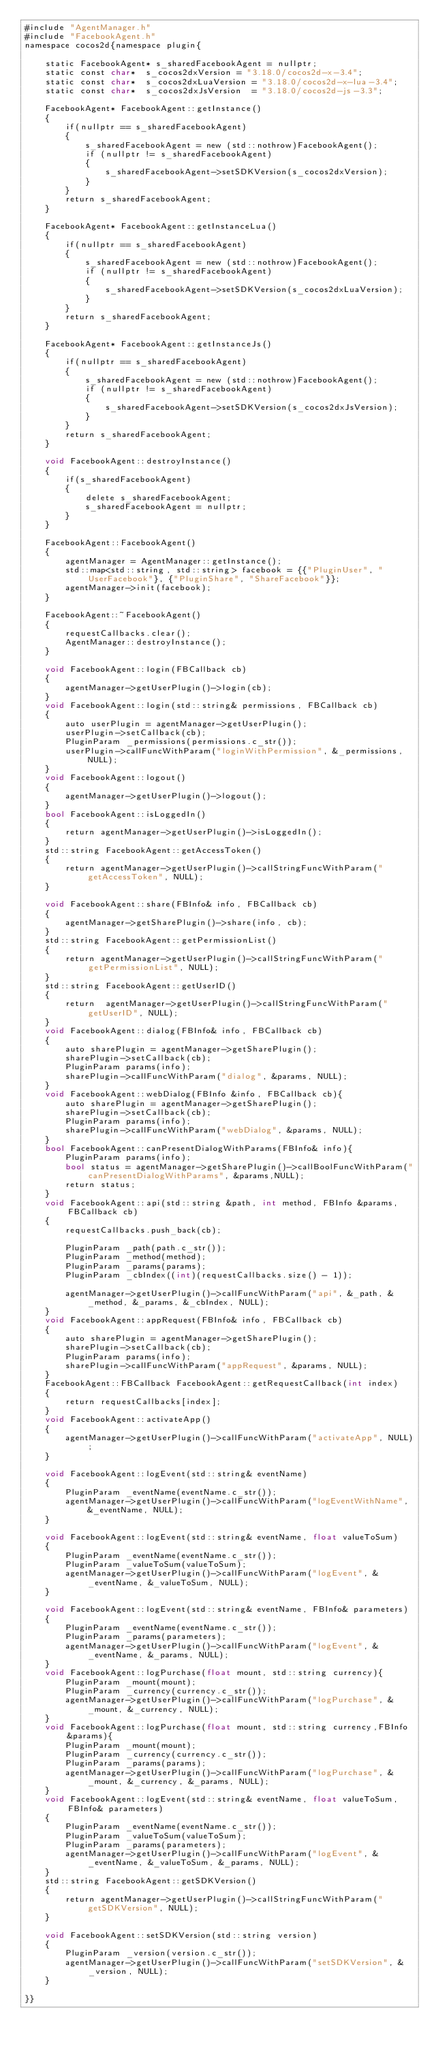<code> <loc_0><loc_0><loc_500><loc_500><_ObjectiveC_>#include "AgentManager.h"
#include "FacebookAgent.h"
namespace cocos2d{namespace plugin{
    
    static FacebookAgent* s_sharedFacebookAgent = nullptr;
    static const char*  s_cocos2dxVersion = "3.18.0/cocos2d-x-3.4";
    static const char*  s_cocos2dxLuaVersion = "3.18.0/cocos2d-x-lua-3.4";
    static const char*  s_cocos2dxJsVersion  = "3.18.0/cocos2d-js-3.3";
    
    FacebookAgent* FacebookAgent::getInstance()
    {
        if(nullptr == s_sharedFacebookAgent)
        {
            s_sharedFacebookAgent = new (std::nothrow)FacebookAgent();
            if (nullptr != s_sharedFacebookAgent)
            {
                s_sharedFacebookAgent->setSDKVersion(s_cocos2dxVersion);
            }
        }
        return s_sharedFacebookAgent;
    }
    
    FacebookAgent* FacebookAgent::getInstanceLua()
    {
        if(nullptr == s_sharedFacebookAgent)
        {
            s_sharedFacebookAgent = new (std::nothrow)FacebookAgent();
            if (nullptr != s_sharedFacebookAgent)
            {
                s_sharedFacebookAgent->setSDKVersion(s_cocos2dxLuaVersion);
            }
        }
        return s_sharedFacebookAgent;
    }
    
    FacebookAgent* FacebookAgent::getInstanceJs()
    {
        if(nullptr == s_sharedFacebookAgent)
        {
            s_sharedFacebookAgent = new (std::nothrow)FacebookAgent();
            if (nullptr != s_sharedFacebookAgent)
            {
                s_sharedFacebookAgent->setSDKVersion(s_cocos2dxJsVersion);
            }
        }
        return s_sharedFacebookAgent;
    }
    
    void FacebookAgent::destroyInstance()
    {
        if(s_sharedFacebookAgent)
        {
            delete s_sharedFacebookAgent;
            s_sharedFacebookAgent = nullptr;
        }
    }
    
    FacebookAgent::FacebookAgent()
    {
        agentManager = AgentManager::getInstance();
        std::map<std::string, std::string> facebook = {{"PluginUser", "UserFacebook"}, {"PluginShare", "ShareFacebook"}};
        agentManager->init(facebook);
    }
    
    FacebookAgent::~FacebookAgent()
    {
        requestCallbacks.clear();
        AgentManager::destroyInstance();
    }
    
    void FacebookAgent::login(FBCallback cb)
    {
        agentManager->getUserPlugin()->login(cb);
    }
    void FacebookAgent::login(std::string& permissions, FBCallback cb)
    {
        auto userPlugin = agentManager->getUserPlugin();
        userPlugin->setCallback(cb);
        PluginParam _permissions(permissions.c_str());
        userPlugin->callFuncWithParam("loginWithPermission", &_permissions, NULL);
    }
    void FacebookAgent::logout()
    {
        agentManager->getUserPlugin()->logout();
    }
    bool FacebookAgent::isLoggedIn()
    {
        return agentManager->getUserPlugin()->isLoggedIn();
    }
    std::string FacebookAgent::getAccessToken()
    {
        return agentManager->getUserPlugin()->callStringFuncWithParam("getAccessToken", NULL);
    }
    
    void FacebookAgent::share(FBInfo& info, FBCallback cb)
    {
        agentManager->getSharePlugin()->share(info, cb);
    }
    std::string FacebookAgent::getPermissionList()
    {
        return agentManager->getUserPlugin()->callStringFuncWithParam("getPermissionList", NULL);
    }
    std::string FacebookAgent::getUserID()
    {
        return  agentManager->getUserPlugin()->callStringFuncWithParam("getUserID", NULL);
    }
    void FacebookAgent::dialog(FBInfo& info, FBCallback cb)
    {
        auto sharePlugin = agentManager->getSharePlugin();
        sharePlugin->setCallback(cb);
        PluginParam params(info);
        sharePlugin->callFuncWithParam("dialog", &params, NULL);
    }
    void FacebookAgent::webDialog(FBInfo &info, FBCallback cb){
        auto sharePlugin = agentManager->getSharePlugin();
        sharePlugin->setCallback(cb);
        PluginParam params(info);
        sharePlugin->callFuncWithParam("webDialog", &params, NULL);
    }
    bool FacebookAgent::canPresentDialogWithParams(FBInfo& info){
        PluginParam params(info);
        bool status = agentManager->getSharePlugin()->callBoolFuncWithParam("canPresentDialogWithParams", &params,NULL);
        return status;
    }
    void FacebookAgent::api(std::string &path, int method, FBInfo &params, FBCallback cb)
    {
        requestCallbacks.push_back(cb);
        
        PluginParam _path(path.c_str());
        PluginParam _method(method);
        PluginParam _params(params);
        PluginParam _cbIndex((int)(requestCallbacks.size() - 1));
        
        agentManager->getUserPlugin()->callFuncWithParam("api", &_path, &_method, &_params, &_cbIndex, NULL);
    }
    void FacebookAgent::appRequest(FBInfo& info, FBCallback cb)
    {
        auto sharePlugin = agentManager->getSharePlugin();
        sharePlugin->setCallback(cb);
        PluginParam params(info);
        sharePlugin->callFuncWithParam("appRequest", &params, NULL);
    }
    FacebookAgent::FBCallback FacebookAgent::getRequestCallback(int index)
    {
        return requestCallbacks[index];
    }
    void FacebookAgent::activateApp()
    {
        agentManager->getUserPlugin()->callFuncWithParam("activateApp", NULL);
    }
    
    void FacebookAgent::logEvent(std::string& eventName)
    {
        PluginParam _eventName(eventName.c_str());
        agentManager->getUserPlugin()->callFuncWithParam("logEventWithName", &_eventName, NULL);
    }
    
    void FacebookAgent::logEvent(std::string& eventName, float valueToSum)
    {
        PluginParam _eventName(eventName.c_str());
        PluginParam _valueToSum(valueToSum);
        agentManager->getUserPlugin()->callFuncWithParam("logEvent", &_eventName, &_valueToSum, NULL);
    }
    
    void FacebookAgent::logEvent(std::string& eventName, FBInfo& parameters)
    {
        PluginParam _eventName(eventName.c_str());
        PluginParam _params(parameters);
        agentManager->getUserPlugin()->callFuncWithParam("logEvent", &_eventName, &_params, NULL);
    }
    void FacebookAgent::logPurchase(float mount, std::string currency){
        PluginParam _mount(mount);
        PluginParam _currency(currency.c_str());
        agentManager->getUserPlugin()->callFuncWithParam("logPurchase", &_mount, &_currency, NULL);
    }
    void FacebookAgent::logPurchase(float mount, std::string currency,FBInfo &params){
        PluginParam _mount(mount);
        PluginParam _currency(currency.c_str());
        PluginParam _params(params);
        agentManager->getUserPlugin()->callFuncWithParam("logPurchase", &_mount, &_currency, &_params, NULL);
    }
    void FacebookAgent::logEvent(std::string& eventName, float valueToSum, FBInfo& parameters)
    {
        PluginParam _eventName(eventName.c_str());
        PluginParam _valueToSum(valueToSum);
        PluginParam _params(parameters);
        agentManager->getUserPlugin()->callFuncWithParam("logEvent", &_eventName, &_valueToSum, &_params, NULL);
    }
    std::string FacebookAgent::getSDKVersion()
    {
        return agentManager->getUserPlugin()->callStringFuncWithParam("getSDKVersion", NULL);
    }

    void FacebookAgent::setSDKVersion(std::string version)
    {
        PluginParam _version(version.c_str());
        agentManager->getUserPlugin()->callFuncWithParam("setSDKVersion", &_version, NULL);
    }

}}
</code> 